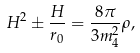Convert formula to latex. <formula><loc_0><loc_0><loc_500><loc_500>H ^ { 2 } \pm \frac { H } { r _ { 0 } } = \frac { 8 \pi } { 3 m ^ { 2 } _ { 4 } } \rho ,</formula> 